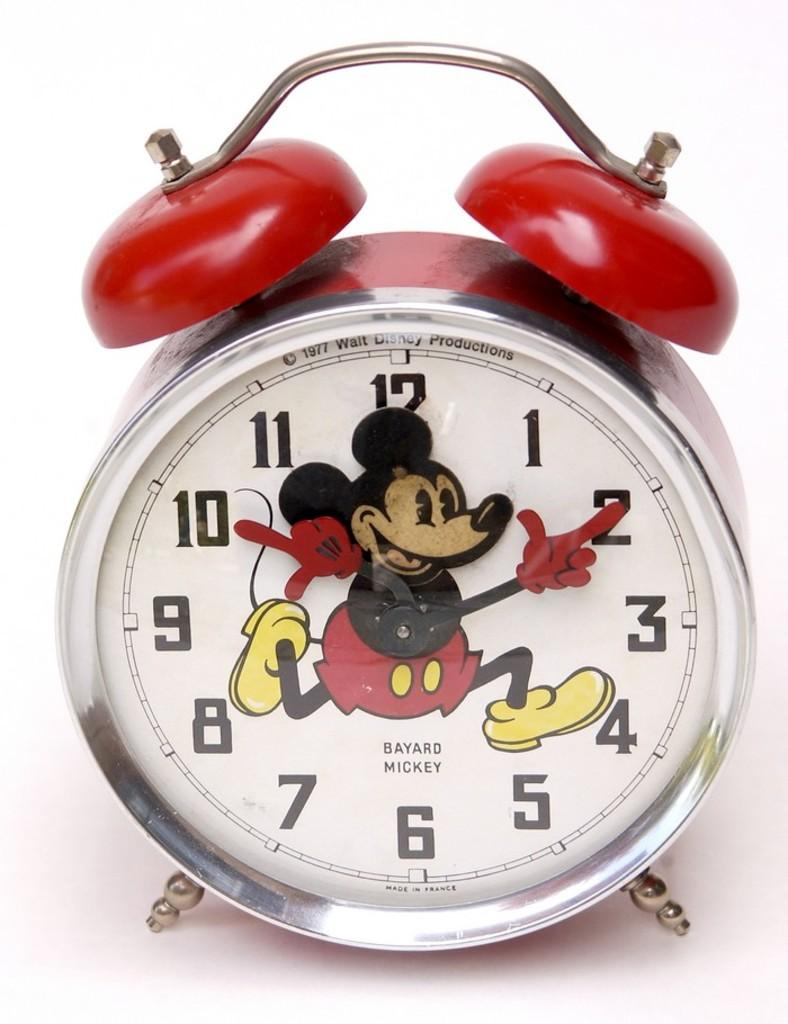<image>
Give a short and clear explanation of the subsequent image. a clock has the number 12 on it and it says Bayard Mickey 